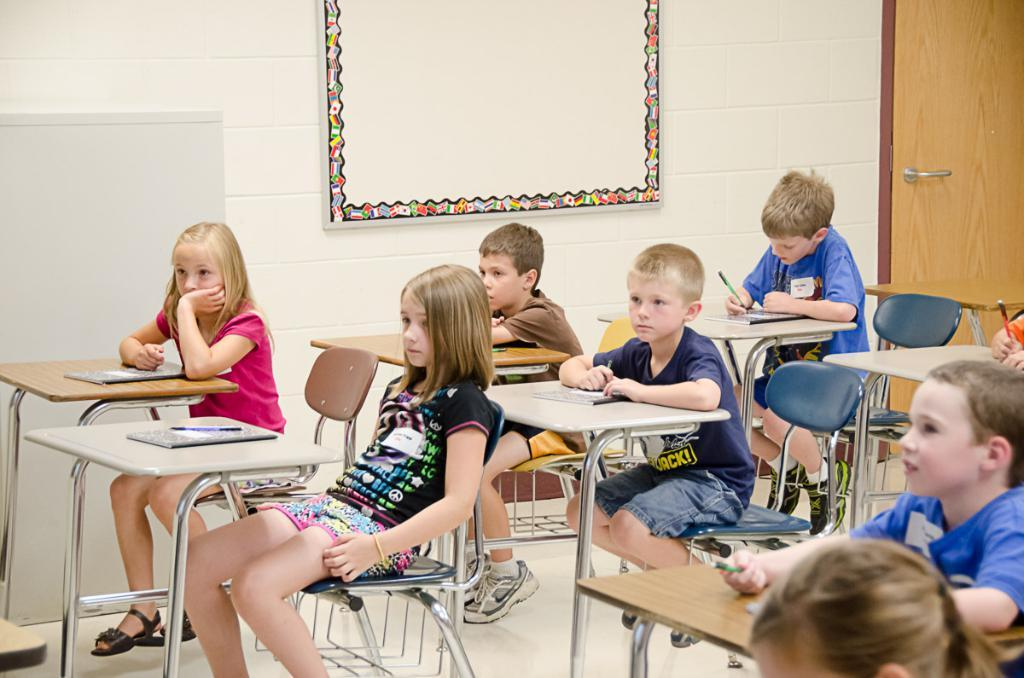Who is present in the image? There are children in the image. Where are the children located? The children are sitting in a classroom. What are the children doing in the image? The children are listening to a teacher. What type of faucet can be seen in the image? There is no faucet present in the image; it features children sitting in a classroom and listening to a teacher. 